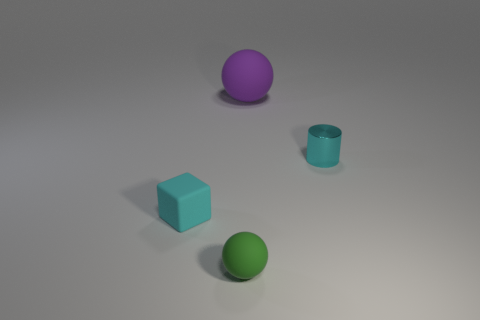Add 1 big cyan metallic cubes. How many objects exist? 5 Subtract all cubes. How many objects are left? 3 Subtract all blue metallic cubes. Subtract all tiny rubber objects. How many objects are left? 2 Add 3 metal cylinders. How many metal cylinders are left? 4 Add 4 large purple things. How many large purple things exist? 5 Subtract 1 cyan cubes. How many objects are left? 3 